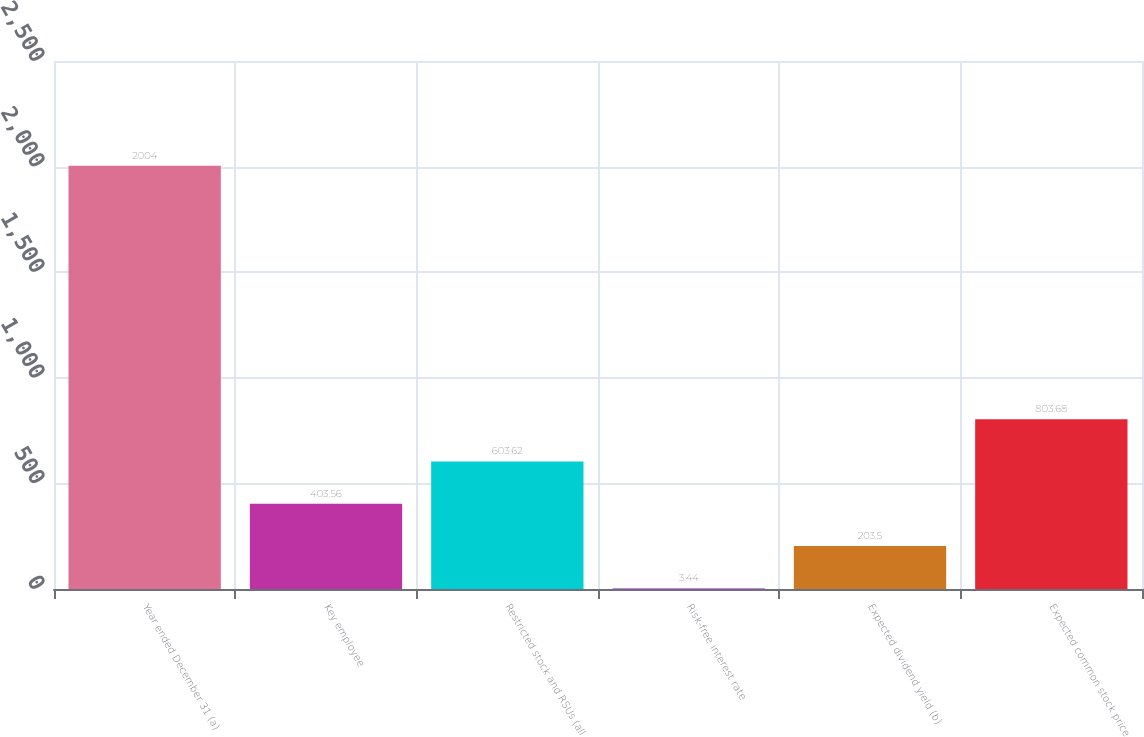<chart> <loc_0><loc_0><loc_500><loc_500><bar_chart><fcel>Year ended December 31 (a)<fcel>Key employee<fcel>Restricted stock and RSUs (all<fcel>Risk-free interest rate<fcel>Expected dividend yield (b)<fcel>Expected common stock price<nl><fcel>2004<fcel>403.56<fcel>603.62<fcel>3.44<fcel>203.5<fcel>803.68<nl></chart> 